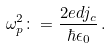<formula> <loc_0><loc_0><loc_500><loc_500>\omega _ { p } ^ { 2 } \colon = \frac { 2 e d j _ { c } } { \hbar { \epsilon } _ { 0 } } \, .</formula> 